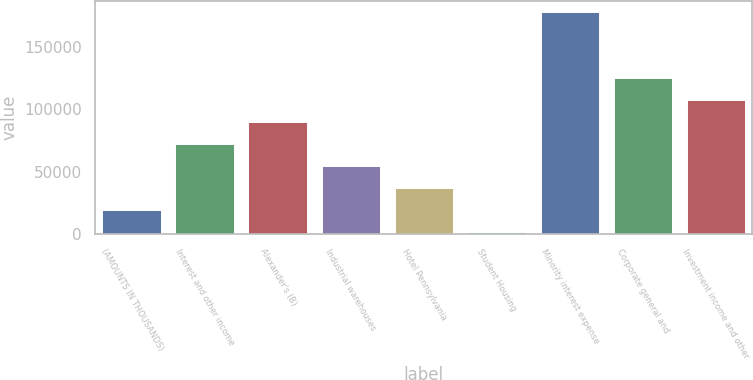Convert chart. <chart><loc_0><loc_0><loc_500><loc_500><bar_chart><fcel>(AMOUNTS IN THOUSANDS)<fcel>Interest and other income<fcel>Alexander's (B)<fcel>Industrial warehouses<fcel>Hotel Pennsylvania<fcel>Student Housing<fcel>Minority interest expense<fcel>Corporate general and<fcel>Investment income and other<nl><fcel>19555.6<fcel>72222.4<fcel>89778<fcel>54666.8<fcel>37111.2<fcel>2000<fcel>177556<fcel>124889<fcel>107334<nl></chart> 